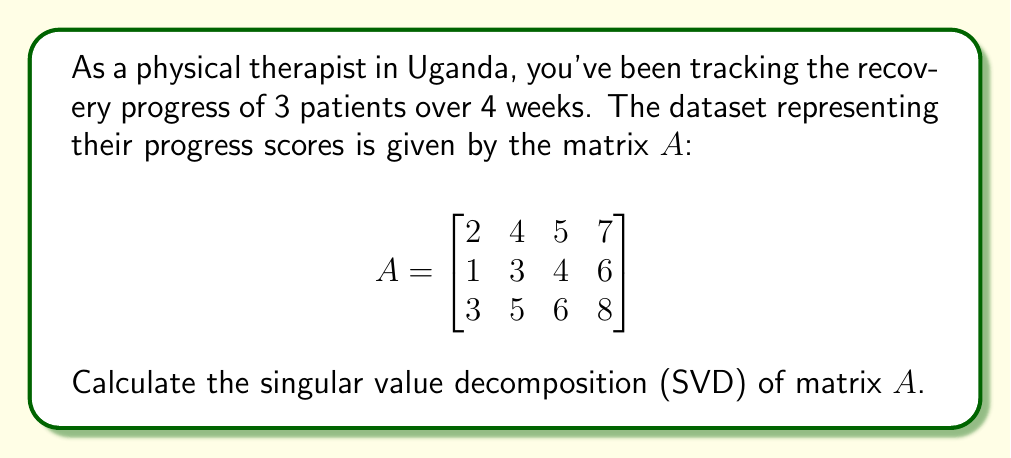Can you answer this question? To calculate the singular value decomposition of matrix $A$, we need to find matrices $U$, $\Sigma$, and $V^T$ such that $A = U\Sigma V^T$. Let's follow these steps:

1) First, calculate $A^TA$:
   $$A^TA = \begin{bmatrix}
   14 & 26 & 32 & 44 \\
   26 & 50 & 62 & 86 \\
   32 & 62 & 77 & 107 \\
   44 & 86 & 107 & 149
   \end{bmatrix}$$

2) Find the eigenvalues of $A^TA$:
   The characteristic equation is $\det(A^TA - \lambda I) = 0$
   Solving this, we get eigenvalues: $\lambda_1 \approx 289.52$, $\lambda_2 \approx 0.48$, $\lambda_3 = \lambda_4 = 0$

3) The singular values are the square roots of these eigenvalues:
   $\sigma_1 \approx 17.02$, $\sigma_2 \approx 0.69$, $\sigma_3 = \sigma_4 = 0$

4) Find the eigenvectors of $A^TA$ to get the columns of $V$:
   $v_1 \approx [0.24, 0.47, 0.58, 0.81]^T$
   $v_2 \approx [-0.67, -0.22, 0.13, 0.70]^T$
   (We don't need $v_3$ and $v_4$ as their corresponding singular values are 0)

5) Calculate $U$ using $U = AV\Sigma^{-1}$:
   $u_1 \approx [0.49, 0.37, 0.79]^T$
   $u_2 \approx [-0.77, 0.63, 0.08]^T$
   (We only need two columns for $U$ as there are only two non-zero singular values)

6) The SVD of $A$ is:

   $$A = U\Sigma V^T \approx 
   \begin{bmatrix}
   0.49 & -0.77 \\
   0.37 & 0.63 \\
   0.79 & 0.08
   \end{bmatrix}
   \begin{bmatrix}
   17.02 & 0 & 0 & 0 \\
   0 & 0.69 & 0 & 0
   \end{bmatrix}
   \begin{bmatrix}
   0.24 & 0.47 & 0.58 & 0.81 \\
   -0.67 & -0.22 & 0.13 & 0.70
   \end{bmatrix}$$
Answer: $A \approx U\Sigma V^T$ where $U = [0.49, -0.77; 0.37, 0.63; 0.79, 0.08]$, $\Sigma = \text{diag}(17.02, 0.69)$, $V^T = [0.24, 0.47, 0.58, 0.81; -0.67, -0.22, 0.13, 0.70]$ 